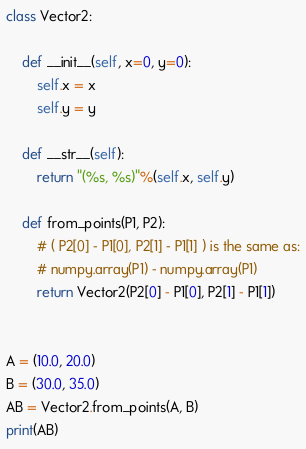Convert code to text. <code><loc_0><loc_0><loc_500><loc_500><_Python_>class Vector2:
    
    def __init__(self, x=0, y=0):        
        self.x = x
        self.y = y
        
    def __str__(self):
        return "(%s, %s)"%(self.x, self.y)
        
    def from_points(P1, P2):
        # ( P2[0] - P1[0], P2[1] - P1[1] ) is the same as:
        # numpy.array(P1) - numpy.array(P1)
        return Vector2(P2[0] - P1[0], P2[1] - P1[1])


A = (10.0, 20.0) 
B = (30.0, 35.0)
AB = Vector2.from_points(A, B)
print(AB)
</code> 